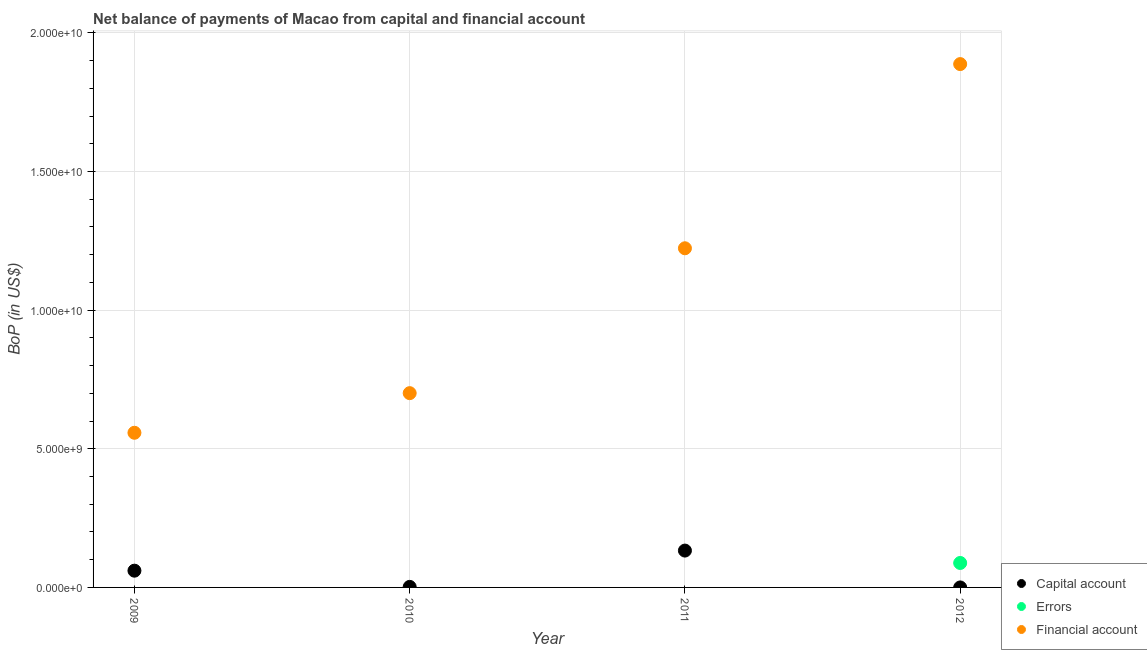Across all years, what is the maximum amount of net capital account?
Ensure brevity in your answer.  1.33e+09. Across all years, what is the minimum amount of financial account?
Offer a terse response. 5.58e+09. What is the total amount of errors in the graph?
Your answer should be very brief. 8.82e+08. What is the difference between the amount of net capital account in 2009 and that in 2010?
Make the answer very short. 5.85e+08. What is the difference between the amount of financial account in 2011 and the amount of net capital account in 2012?
Provide a succinct answer. 1.22e+1. What is the average amount of errors per year?
Offer a terse response. 2.21e+08. In the year 2011, what is the difference between the amount of financial account and amount of net capital account?
Provide a short and direct response. 1.09e+1. What is the ratio of the amount of financial account in 2010 to that in 2011?
Your response must be concise. 0.57. What is the difference between the highest and the second highest amount of net capital account?
Ensure brevity in your answer.  7.25e+08. What is the difference between the highest and the lowest amount of net capital account?
Provide a short and direct response. 1.33e+09. Is the sum of the amount of net capital account in 2010 and 2011 greater than the maximum amount of errors across all years?
Your answer should be very brief. Yes. Is it the case that in every year, the sum of the amount of net capital account and amount of errors is greater than the amount of financial account?
Ensure brevity in your answer.  No. Does the amount of net capital account monotonically increase over the years?
Your answer should be compact. No. Is the amount of net capital account strictly greater than the amount of errors over the years?
Your response must be concise. No. Is the amount of errors strictly less than the amount of financial account over the years?
Offer a very short reply. Yes. How many years are there in the graph?
Make the answer very short. 4. Are the values on the major ticks of Y-axis written in scientific E-notation?
Provide a succinct answer. Yes. Does the graph contain grids?
Your response must be concise. Yes. Where does the legend appear in the graph?
Your response must be concise. Bottom right. What is the title of the graph?
Your answer should be compact. Net balance of payments of Macao from capital and financial account. Does "Taxes" appear as one of the legend labels in the graph?
Your answer should be very brief. No. What is the label or title of the Y-axis?
Your response must be concise. BoP (in US$). What is the BoP (in US$) of Capital account in 2009?
Ensure brevity in your answer.  6.04e+08. What is the BoP (in US$) of Financial account in 2009?
Offer a terse response. 5.58e+09. What is the BoP (in US$) of Capital account in 2010?
Keep it short and to the point. 1.96e+07. What is the BoP (in US$) in Errors in 2010?
Give a very brief answer. 0. What is the BoP (in US$) in Financial account in 2010?
Your response must be concise. 7.01e+09. What is the BoP (in US$) in Capital account in 2011?
Offer a very short reply. 1.33e+09. What is the BoP (in US$) of Errors in 2011?
Your answer should be compact. 0. What is the BoP (in US$) in Financial account in 2011?
Your response must be concise. 1.22e+1. What is the BoP (in US$) of Errors in 2012?
Your response must be concise. 8.82e+08. What is the BoP (in US$) of Financial account in 2012?
Your answer should be compact. 1.89e+1. Across all years, what is the maximum BoP (in US$) of Capital account?
Offer a very short reply. 1.33e+09. Across all years, what is the maximum BoP (in US$) of Errors?
Ensure brevity in your answer.  8.82e+08. Across all years, what is the maximum BoP (in US$) in Financial account?
Provide a short and direct response. 1.89e+1. Across all years, what is the minimum BoP (in US$) of Capital account?
Your response must be concise. 0. Across all years, what is the minimum BoP (in US$) of Financial account?
Offer a very short reply. 5.58e+09. What is the total BoP (in US$) in Capital account in the graph?
Your response must be concise. 1.95e+09. What is the total BoP (in US$) in Errors in the graph?
Give a very brief answer. 8.82e+08. What is the total BoP (in US$) in Financial account in the graph?
Give a very brief answer. 4.37e+1. What is the difference between the BoP (in US$) in Capital account in 2009 and that in 2010?
Give a very brief answer. 5.85e+08. What is the difference between the BoP (in US$) of Financial account in 2009 and that in 2010?
Your response must be concise. -1.43e+09. What is the difference between the BoP (in US$) in Capital account in 2009 and that in 2011?
Your response must be concise. -7.25e+08. What is the difference between the BoP (in US$) in Financial account in 2009 and that in 2011?
Give a very brief answer. -6.65e+09. What is the difference between the BoP (in US$) of Financial account in 2009 and that in 2012?
Ensure brevity in your answer.  -1.33e+1. What is the difference between the BoP (in US$) of Capital account in 2010 and that in 2011?
Make the answer very short. -1.31e+09. What is the difference between the BoP (in US$) of Financial account in 2010 and that in 2011?
Keep it short and to the point. -5.23e+09. What is the difference between the BoP (in US$) in Financial account in 2010 and that in 2012?
Your answer should be compact. -1.19e+1. What is the difference between the BoP (in US$) of Financial account in 2011 and that in 2012?
Your response must be concise. -6.64e+09. What is the difference between the BoP (in US$) of Capital account in 2009 and the BoP (in US$) of Financial account in 2010?
Your response must be concise. -6.40e+09. What is the difference between the BoP (in US$) of Capital account in 2009 and the BoP (in US$) of Financial account in 2011?
Give a very brief answer. -1.16e+1. What is the difference between the BoP (in US$) in Capital account in 2009 and the BoP (in US$) in Errors in 2012?
Your answer should be compact. -2.78e+08. What is the difference between the BoP (in US$) of Capital account in 2009 and the BoP (in US$) of Financial account in 2012?
Provide a short and direct response. -1.83e+1. What is the difference between the BoP (in US$) of Capital account in 2010 and the BoP (in US$) of Financial account in 2011?
Offer a very short reply. -1.22e+1. What is the difference between the BoP (in US$) in Capital account in 2010 and the BoP (in US$) in Errors in 2012?
Your answer should be very brief. -8.62e+08. What is the difference between the BoP (in US$) of Capital account in 2010 and the BoP (in US$) of Financial account in 2012?
Give a very brief answer. -1.89e+1. What is the difference between the BoP (in US$) in Capital account in 2011 and the BoP (in US$) in Errors in 2012?
Your answer should be very brief. 4.47e+08. What is the difference between the BoP (in US$) in Capital account in 2011 and the BoP (in US$) in Financial account in 2012?
Give a very brief answer. -1.75e+1. What is the average BoP (in US$) of Capital account per year?
Make the answer very short. 4.88e+08. What is the average BoP (in US$) in Errors per year?
Ensure brevity in your answer.  2.21e+08. What is the average BoP (in US$) in Financial account per year?
Provide a short and direct response. 1.09e+1. In the year 2009, what is the difference between the BoP (in US$) in Capital account and BoP (in US$) in Financial account?
Your answer should be compact. -4.97e+09. In the year 2010, what is the difference between the BoP (in US$) in Capital account and BoP (in US$) in Financial account?
Your answer should be very brief. -6.99e+09. In the year 2011, what is the difference between the BoP (in US$) in Capital account and BoP (in US$) in Financial account?
Offer a terse response. -1.09e+1. In the year 2012, what is the difference between the BoP (in US$) in Errors and BoP (in US$) in Financial account?
Provide a short and direct response. -1.80e+1. What is the ratio of the BoP (in US$) of Capital account in 2009 to that in 2010?
Provide a short and direct response. 30.83. What is the ratio of the BoP (in US$) of Financial account in 2009 to that in 2010?
Your answer should be very brief. 0.8. What is the ratio of the BoP (in US$) of Capital account in 2009 to that in 2011?
Offer a terse response. 0.45. What is the ratio of the BoP (in US$) in Financial account in 2009 to that in 2011?
Keep it short and to the point. 0.46. What is the ratio of the BoP (in US$) in Financial account in 2009 to that in 2012?
Make the answer very short. 0.3. What is the ratio of the BoP (in US$) of Capital account in 2010 to that in 2011?
Your response must be concise. 0.01. What is the ratio of the BoP (in US$) of Financial account in 2010 to that in 2011?
Your response must be concise. 0.57. What is the ratio of the BoP (in US$) in Financial account in 2010 to that in 2012?
Provide a succinct answer. 0.37. What is the ratio of the BoP (in US$) of Financial account in 2011 to that in 2012?
Ensure brevity in your answer.  0.65. What is the difference between the highest and the second highest BoP (in US$) in Capital account?
Give a very brief answer. 7.25e+08. What is the difference between the highest and the second highest BoP (in US$) in Financial account?
Offer a very short reply. 6.64e+09. What is the difference between the highest and the lowest BoP (in US$) in Capital account?
Provide a succinct answer. 1.33e+09. What is the difference between the highest and the lowest BoP (in US$) of Errors?
Provide a succinct answer. 8.82e+08. What is the difference between the highest and the lowest BoP (in US$) of Financial account?
Give a very brief answer. 1.33e+1. 